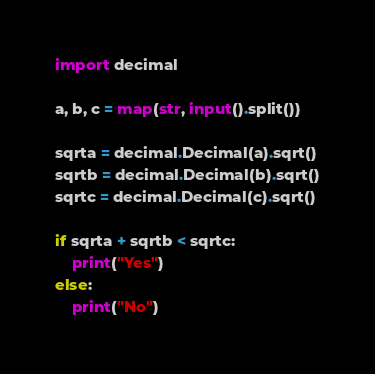Convert code to text. <code><loc_0><loc_0><loc_500><loc_500><_Python_>import decimal

a, b, c = map(str, input().split())

sqrta = decimal.Decimal(a).sqrt()
sqrtb = decimal.Decimal(b).sqrt()
sqrtc = decimal.Decimal(c).sqrt()

if sqrta + sqrtb < sqrtc:
    print("Yes")
else:
    print("No")</code> 